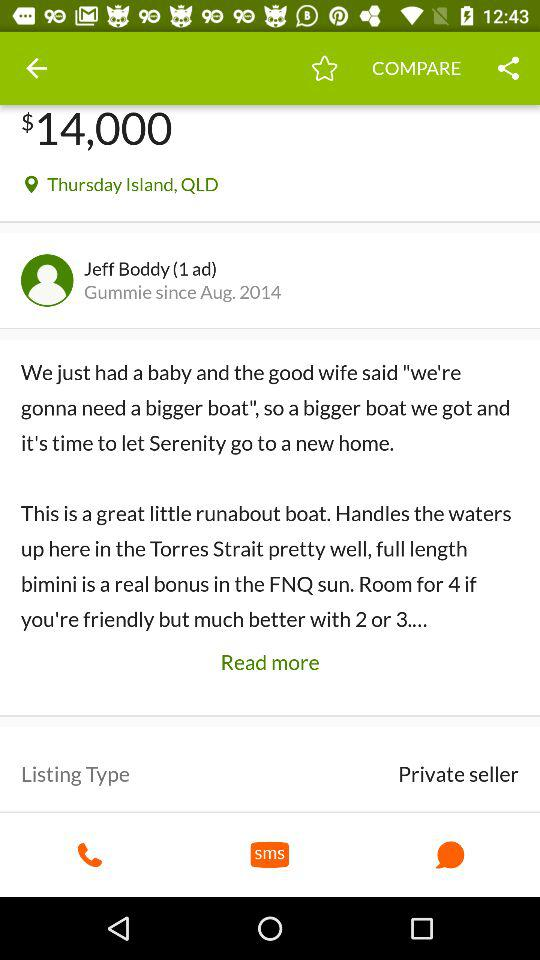What's the user profile name? The user profile name is Jeff Boddy. 